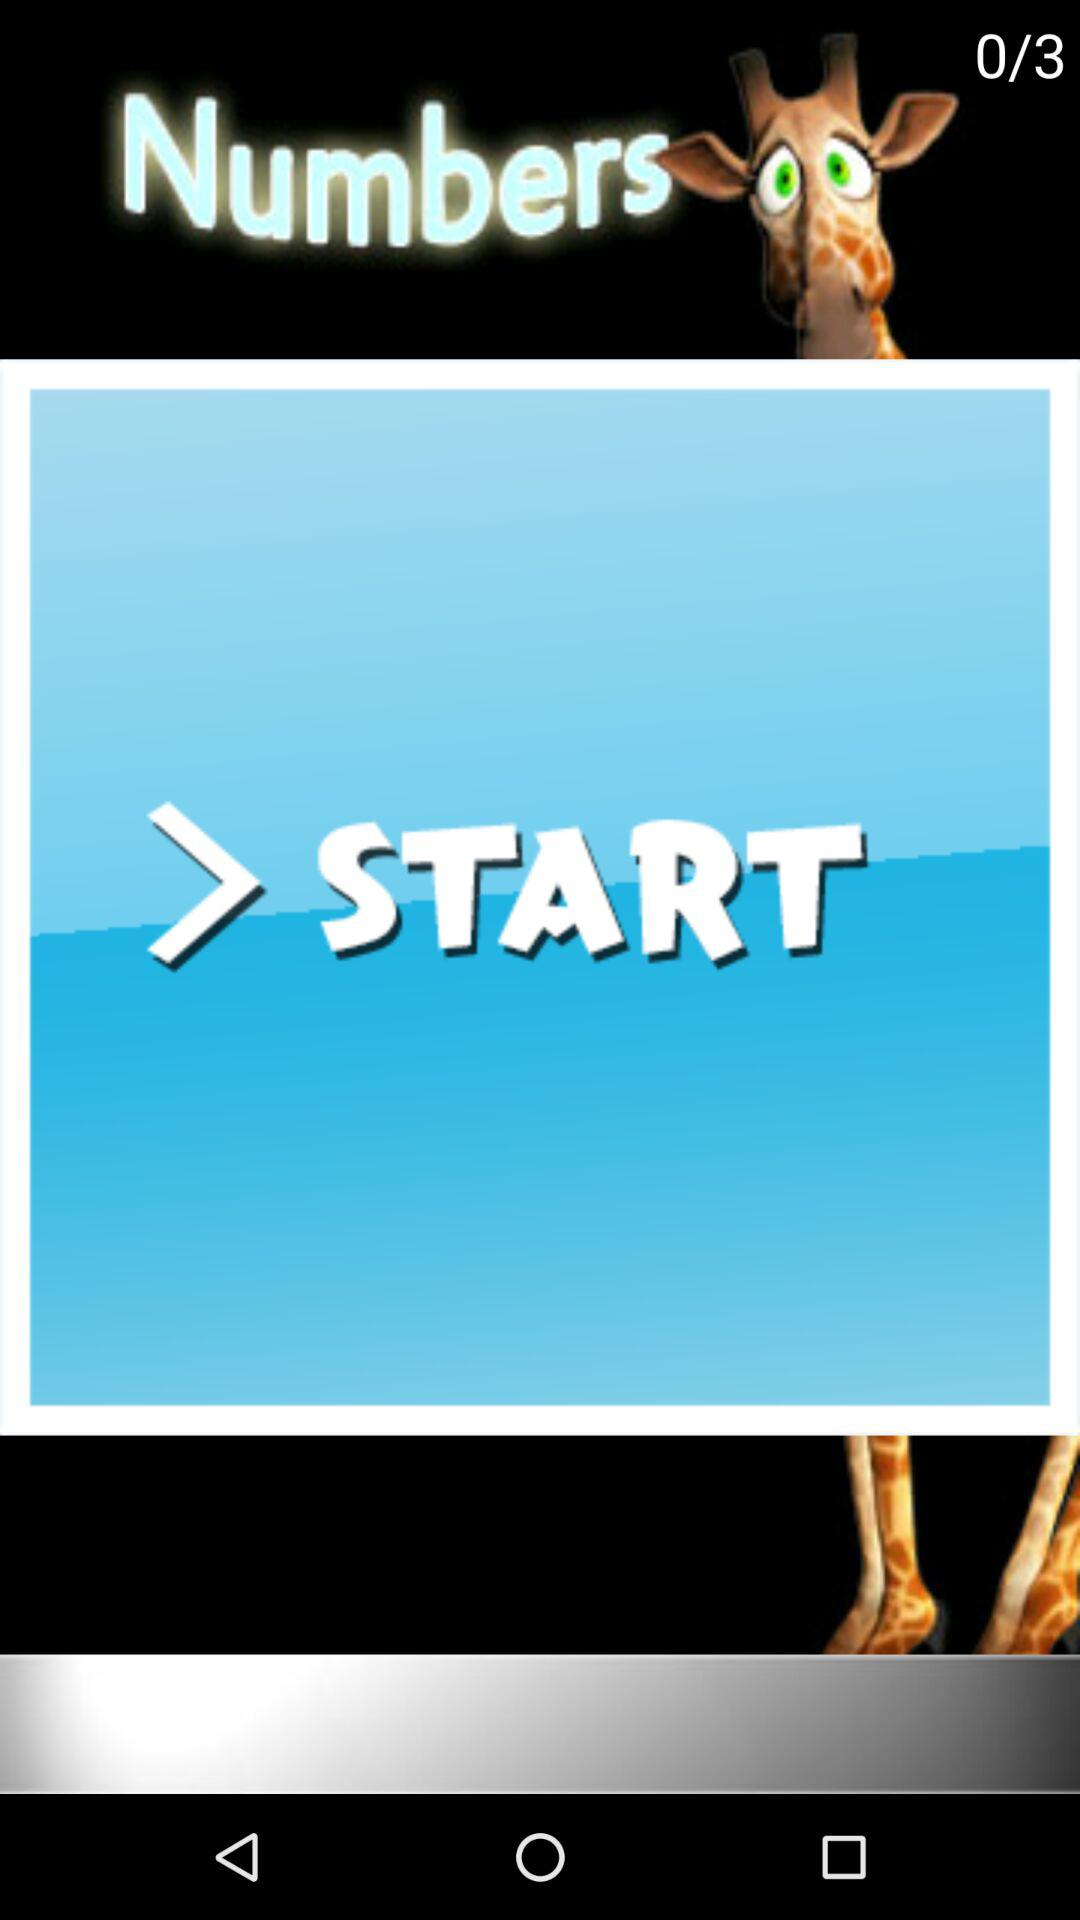What is the total number of steps? The total number of steps is 3. 